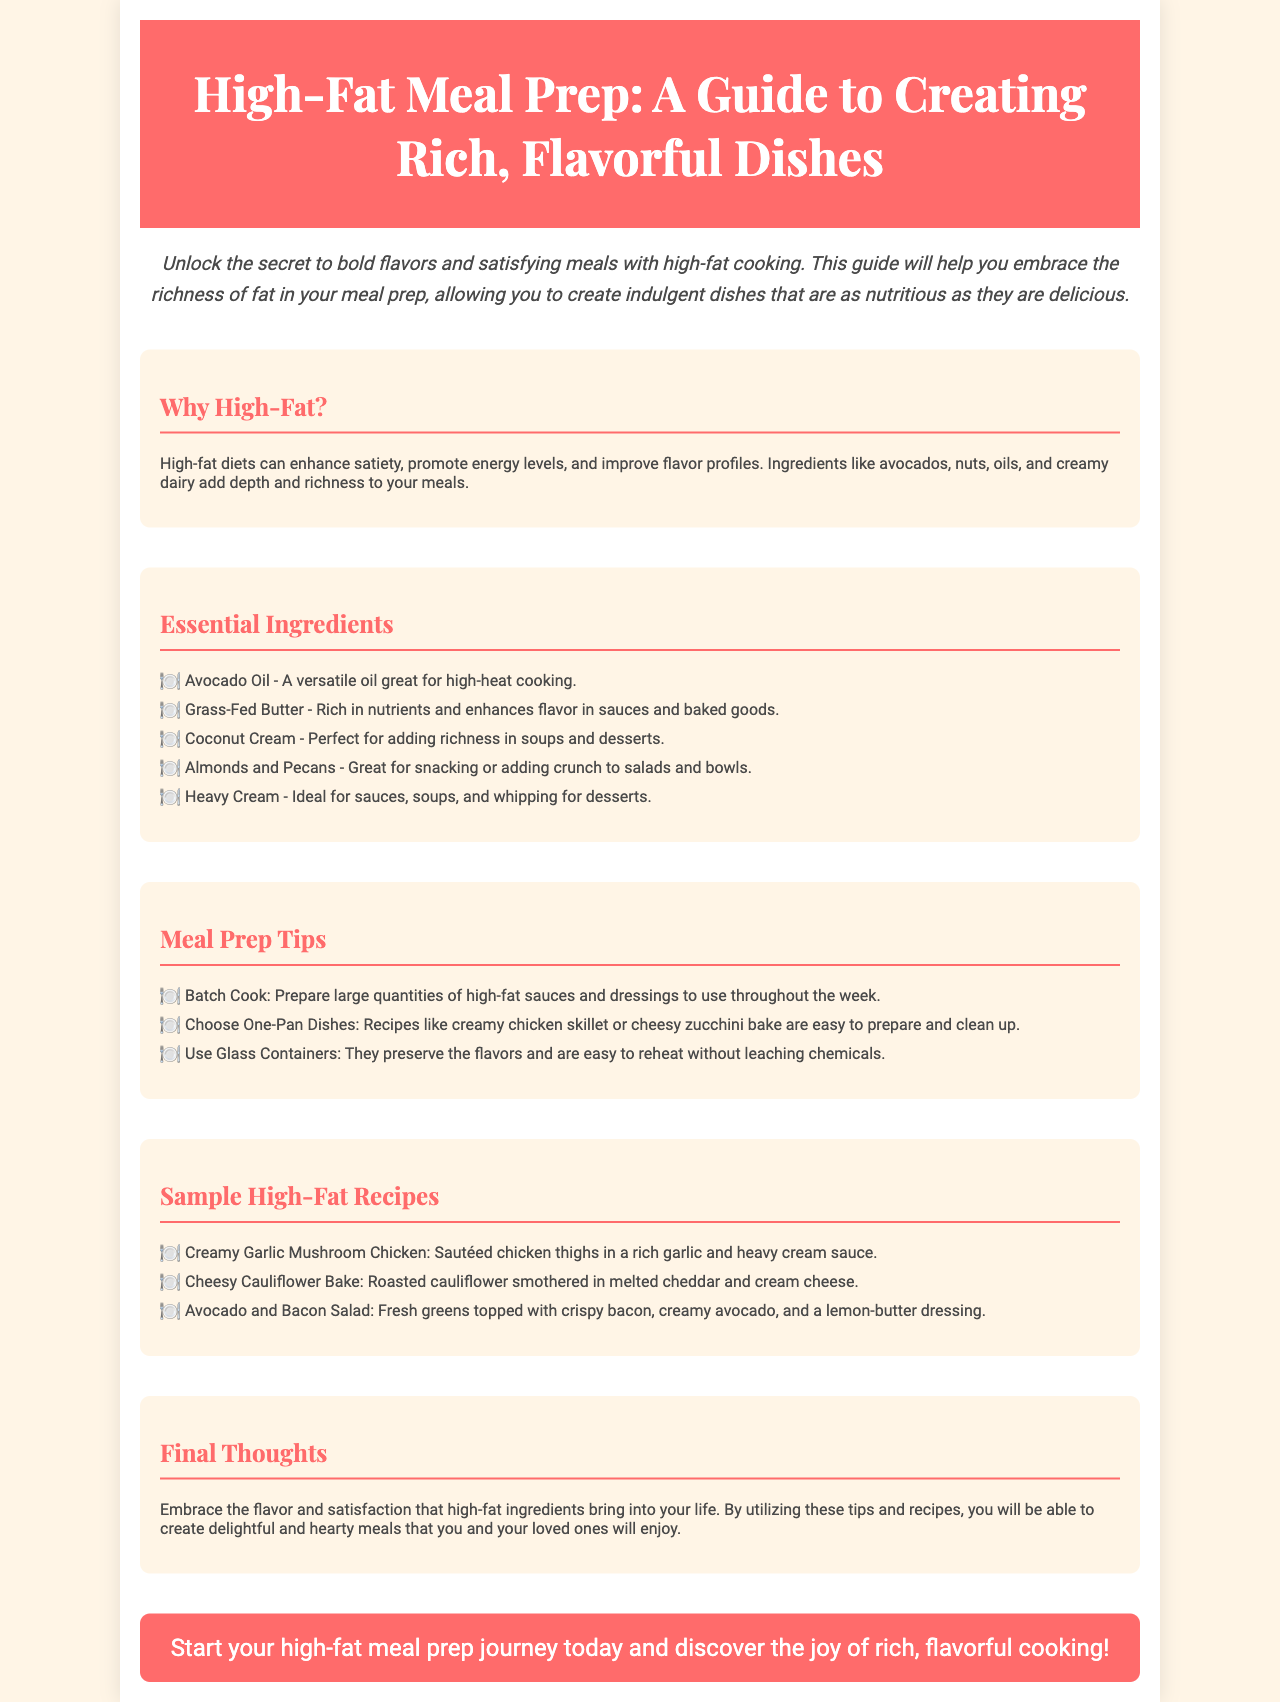What is the title of the brochure? The title of the brochure is mentioned prominently in the header section.
Answer: High-Fat Meal Prep: A Guide to Creating Rich, Flavorful Dishes What is one essential ingredient listed? The document includes a list of essential ingredients for high-fat cooking.
Answer: Avocado Oil What are two benefits of high-fat diets? The document mentions specific benefits of high-fat diets in the "Why High-Fat?" section.
Answer: Enhance satiety, promote energy levels Name one meal prep tip. The section on meal prep tips provides several suggestions for effective cooking.
Answer: Batch Cook List one sample high-fat recipe. The brochure includes a list of sample recipes in the corresponding section.
Answer: Creamy Garlic Mushroom Chicken What is the background color of the brochure? The document describes the overall design elements, including the background color.
Answer: #FFF5E6 How many essential ingredients are mentioned? The document provides a list of five essential ingredients in the corresponding section.
Answer: Five What is the expected outcome of using high-fat ingredients according to the document? The "Final Thoughts" section summarizes the desired impact of high-fat cooking on meals.
Answer: Delightful and hearty meals 